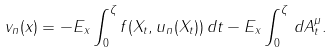<formula> <loc_0><loc_0><loc_500><loc_500>v _ { n } ( x ) = - E _ { x } \int _ { 0 } ^ { \zeta } f ( X _ { t } , u _ { n } ( X _ { t } ) ) \, d t - E _ { x } \int _ { 0 } ^ { \zeta } \, d A ^ { \mu } _ { t } .</formula> 